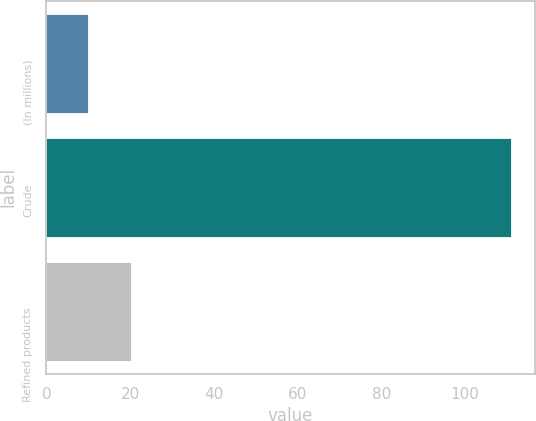Convert chart to OTSL. <chart><loc_0><loc_0><loc_500><loc_500><bar_chart><fcel>(In millions)<fcel>Crude<fcel>Refined products<nl><fcel>10<fcel>111<fcel>20.1<nl></chart> 